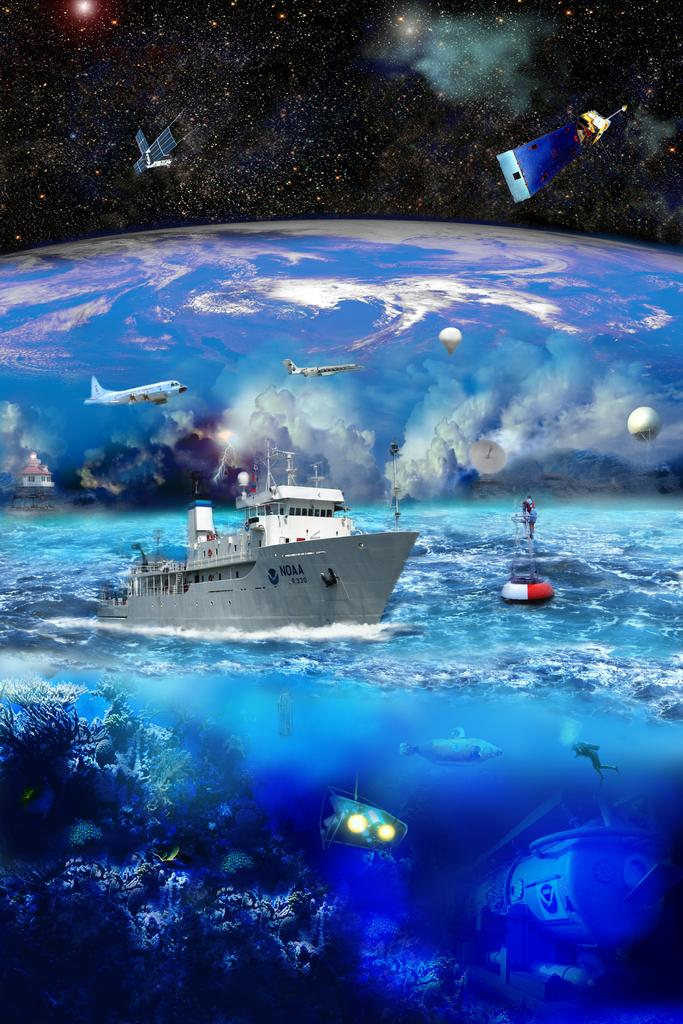What type of vehicle is in the water in the image? There is a ship in the water in the image. What other modes of transportation can be seen in the image? There is an airplane, a satellite, and a hot air balloon in the image. What is the water marine doing in the image? The water marine is not mentioned in the provided facts, so it cannot be determined from the image. What type of structure is present in the image? There is a building in the image. What celestial object is visible in the image? There is a galaxy in the image. What is the condition of the sky in the image? The sky in the image is cloudy. What type of knee injury can be seen in the image? There is no mention of a knee or any injury in the provided facts, so it cannot be determined from the image. What is the mindset of the people in the image? There are no people present in the image, so it cannot be determined from the image. 